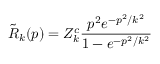Convert formula to latex. <formula><loc_0><loc_0><loc_500><loc_500>\tilde { R } _ { k } ( p ) = Z _ { k } ^ { c } \frac { p ^ { 2 } e ^ { - p ^ { 2 } / k ^ { 2 } } } { 1 - e ^ { - p ^ { 2 } / k ^ { 2 } } }</formula> 